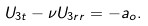<formula> <loc_0><loc_0><loc_500><loc_500>U _ { 3 t } - \nu U _ { 3 r r } = - a _ { o } .</formula> 